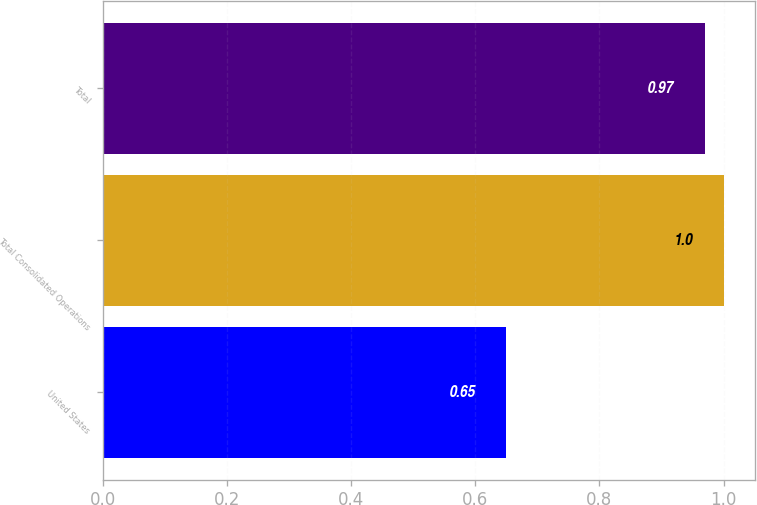Convert chart. <chart><loc_0><loc_0><loc_500><loc_500><bar_chart><fcel>United States<fcel>Total Consolidated Operations<fcel>Total<nl><fcel>0.65<fcel>1<fcel>0.97<nl></chart> 